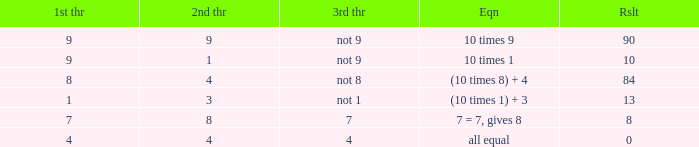If the equation is (10 times 8) + 4, what would be the 2nd throw? 4.0. 